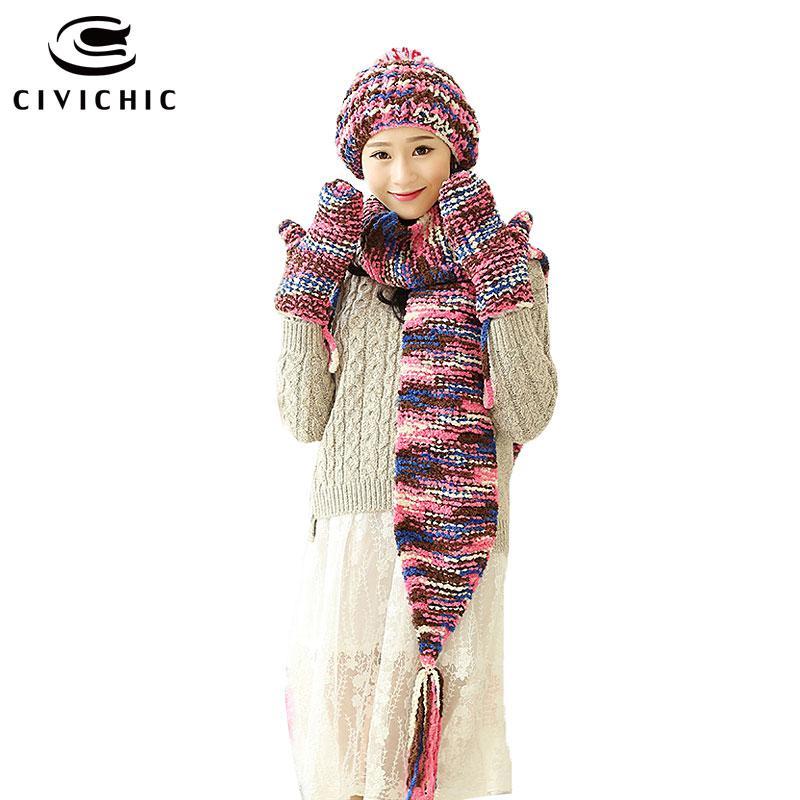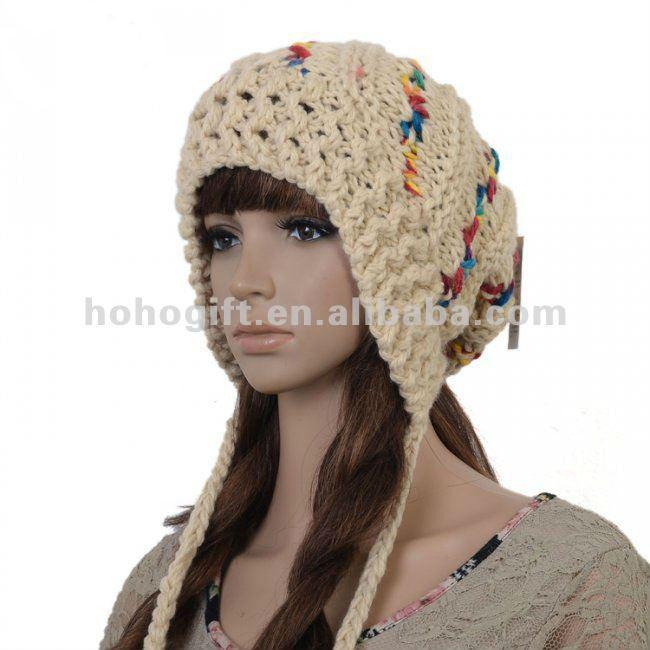The first image is the image on the left, the second image is the image on the right. For the images shown, is this caption "Both women are wearing hats with pom poms." true? Answer yes or no. No. The first image is the image on the left, the second image is the image on the right. For the images shown, is this caption "In one image, a girl is wearing matching hat, mittens and scarf, into which a stripe design has been knitted, with one long end of the scarf draped in front of her." true? Answer yes or no. Yes. 